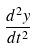Convert formula to latex. <formula><loc_0><loc_0><loc_500><loc_500>\frac { d ^ { 2 } y } { d t ^ { 2 } }</formula> 